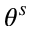Convert formula to latex. <formula><loc_0><loc_0><loc_500><loc_500>\theta ^ { s }</formula> 